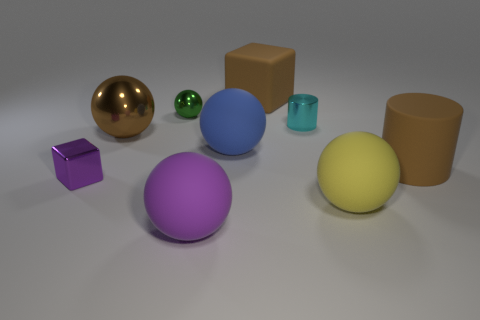Do the large matte block and the big matte cylinder have the same color?
Ensure brevity in your answer.  Yes. There is a large cylinder that is the same color as the rubber cube; what is it made of?
Your answer should be very brief. Rubber. Is the color of the matte cube the same as the cylinder that is in front of the big brown sphere?
Give a very brief answer. Yes. Is there a metallic thing on the right side of the big ball that is on the right side of the small shiny cylinder?
Provide a short and direct response. No. How many other things are the same shape as the large blue thing?
Your response must be concise. 4. Do the large blue matte thing and the large yellow matte thing have the same shape?
Offer a very short reply. Yes. There is a object that is both on the left side of the big purple matte ball and in front of the big metal ball; what is its color?
Make the answer very short. Purple. What is the size of the cylinder that is the same color as the large metallic sphere?
Keep it short and to the point. Large. How many large objects are either rubber objects or blue rubber things?
Provide a short and direct response. 5. Are there any other things of the same color as the small block?
Ensure brevity in your answer.  Yes. 